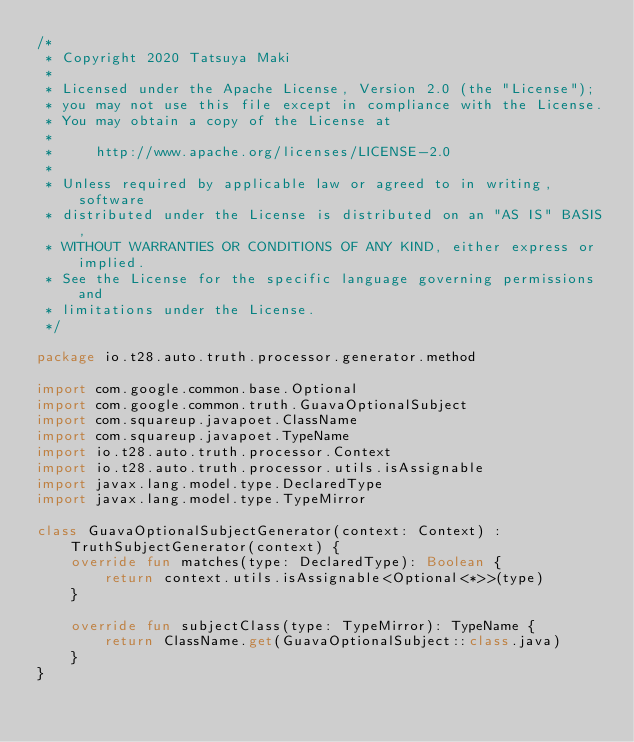Convert code to text. <code><loc_0><loc_0><loc_500><loc_500><_Kotlin_>/*
 * Copyright 2020 Tatsuya Maki
 *
 * Licensed under the Apache License, Version 2.0 (the "License");
 * you may not use this file except in compliance with the License.
 * You may obtain a copy of the License at
 *
 *     http://www.apache.org/licenses/LICENSE-2.0
 *
 * Unless required by applicable law or agreed to in writing, software
 * distributed under the License is distributed on an "AS IS" BASIS,
 * WITHOUT WARRANTIES OR CONDITIONS OF ANY KIND, either express or implied.
 * See the License for the specific language governing permissions and
 * limitations under the License.
 */

package io.t28.auto.truth.processor.generator.method

import com.google.common.base.Optional
import com.google.common.truth.GuavaOptionalSubject
import com.squareup.javapoet.ClassName
import com.squareup.javapoet.TypeName
import io.t28.auto.truth.processor.Context
import io.t28.auto.truth.processor.utils.isAssignable
import javax.lang.model.type.DeclaredType
import javax.lang.model.type.TypeMirror

class GuavaOptionalSubjectGenerator(context: Context) : TruthSubjectGenerator(context) {
    override fun matches(type: DeclaredType): Boolean {
        return context.utils.isAssignable<Optional<*>>(type)
    }

    override fun subjectClass(type: TypeMirror): TypeName {
        return ClassName.get(GuavaOptionalSubject::class.java)
    }
}
</code> 